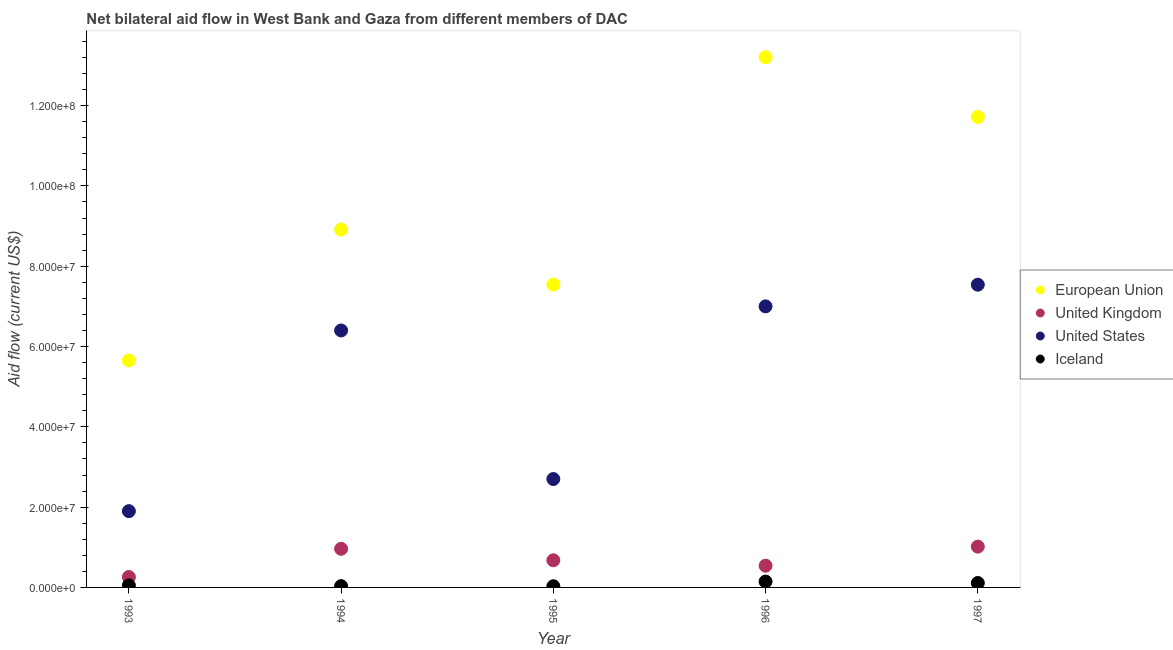How many different coloured dotlines are there?
Make the answer very short. 4. What is the amount of aid given by us in 1994?
Your response must be concise. 6.40e+07. Across all years, what is the maximum amount of aid given by uk?
Your response must be concise. 1.02e+07. Across all years, what is the minimum amount of aid given by us?
Provide a succinct answer. 1.90e+07. In which year was the amount of aid given by uk maximum?
Offer a very short reply. 1997. In which year was the amount of aid given by eu minimum?
Keep it short and to the point. 1993. What is the total amount of aid given by iceland in the graph?
Provide a succinct answer. 3.67e+06. What is the difference between the amount of aid given by iceland in 1996 and that in 1997?
Make the answer very short. 3.60e+05. What is the difference between the amount of aid given by iceland in 1994 and the amount of aid given by eu in 1993?
Offer a terse response. -5.62e+07. What is the average amount of aid given by iceland per year?
Your response must be concise. 7.34e+05. In the year 1997, what is the difference between the amount of aid given by uk and amount of aid given by eu?
Make the answer very short. -1.07e+08. What is the ratio of the amount of aid given by iceland in 1994 to that in 1996?
Ensure brevity in your answer.  0.22. Is the amount of aid given by uk in 1993 less than that in 1997?
Keep it short and to the point. Yes. Is the difference between the amount of aid given by us in 1995 and 1997 greater than the difference between the amount of aid given by eu in 1995 and 1997?
Keep it short and to the point. No. What is the difference between the highest and the second highest amount of aid given by eu?
Offer a terse response. 1.49e+07. What is the difference between the highest and the lowest amount of aid given by uk?
Give a very brief answer. 7.57e+06. In how many years, is the amount of aid given by eu greater than the average amount of aid given by eu taken over all years?
Ensure brevity in your answer.  2. Is the sum of the amount of aid given by iceland in 1994 and 1996 greater than the maximum amount of aid given by uk across all years?
Offer a very short reply. No. Is it the case that in every year, the sum of the amount of aid given by eu and amount of aid given by uk is greater than the amount of aid given by us?
Provide a short and direct response. Yes. Is the amount of aid given by us strictly less than the amount of aid given by eu over the years?
Ensure brevity in your answer.  Yes. What is the difference between two consecutive major ticks on the Y-axis?
Provide a short and direct response. 2.00e+07. Are the values on the major ticks of Y-axis written in scientific E-notation?
Give a very brief answer. Yes. Does the graph contain any zero values?
Offer a very short reply. No. Where does the legend appear in the graph?
Offer a very short reply. Center right. How are the legend labels stacked?
Provide a short and direct response. Vertical. What is the title of the graph?
Provide a short and direct response. Net bilateral aid flow in West Bank and Gaza from different members of DAC. Does "Secondary general" appear as one of the legend labels in the graph?
Offer a very short reply. No. What is the label or title of the X-axis?
Your answer should be compact. Year. What is the Aid flow (current US$) in European Union in 1993?
Give a very brief answer. 5.65e+07. What is the Aid flow (current US$) of United Kingdom in 1993?
Provide a short and direct response. 2.59e+06. What is the Aid flow (current US$) in United States in 1993?
Your answer should be very brief. 1.90e+07. What is the Aid flow (current US$) of Iceland in 1993?
Give a very brief answer. 5.00e+05. What is the Aid flow (current US$) of European Union in 1994?
Offer a terse response. 8.91e+07. What is the Aid flow (current US$) in United Kingdom in 1994?
Provide a short and direct response. 9.62e+06. What is the Aid flow (current US$) in United States in 1994?
Provide a succinct answer. 6.40e+07. What is the Aid flow (current US$) in European Union in 1995?
Your answer should be very brief. 7.54e+07. What is the Aid flow (current US$) in United Kingdom in 1995?
Keep it short and to the point. 6.76e+06. What is the Aid flow (current US$) of United States in 1995?
Offer a very short reply. 2.70e+07. What is the Aid flow (current US$) in European Union in 1996?
Offer a very short reply. 1.32e+08. What is the Aid flow (current US$) in United Kingdom in 1996?
Give a very brief answer. 5.41e+06. What is the Aid flow (current US$) in United States in 1996?
Keep it short and to the point. 7.00e+07. What is the Aid flow (current US$) of Iceland in 1996?
Your response must be concise. 1.46e+06. What is the Aid flow (current US$) in European Union in 1997?
Provide a succinct answer. 1.17e+08. What is the Aid flow (current US$) in United Kingdom in 1997?
Give a very brief answer. 1.02e+07. What is the Aid flow (current US$) of United States in 1997?
Keep it short and to the point. 7.54e+07. What is the Aid flow (current US$) in Iceland in 1997?
Make the answer very short. 1.10e+06. Across all years, what is the maximum Aid flow (current US$) in European Union?
Make the answer very short. 1.32e+08. Across all years, what is the maximum Aid flow (current US$) in United Kingdom?
Your answer should be very brief. 1.02e+07. Across all years, what is the maximum Aid flow (current US$) of United States?
Make the answer very short. 7.54e+07. Across all years, what is the maximum Aid flow (current US$) in Iceland?
Your response must be concise. 1.46e+06. Across all years, what is the minimum Aid flow (current US$) of European Union?
Your answer should be compact. 5.65e+07. Across all years, what is the minimum Aid flow (current US$) in United Kingdom?
Your answer should be very brief. 2.59e+06. Across all years, what is the minimum Aid flow (current US$) of United States?
Your response must be concise. 1.90e+07. What is the total Aid flow (current US$) of European Union in the graph?
Offer a terse response. 4.70e+08. What is the total Aid flow (current US$) of United Kingdom in the graph?
Provide a succinct answer. 3.45e+07. What is the total Aid flow (current US$) in United States in the graph?
Your response must be concise. 2.55e+08. What is the total Aid flow (current US$) in Iceland in the graph?
Provide a short and direct response. 3.67e+06. What is the difference between the Aid flow (current US$) in European Union in 1993 and that in 1994?
Your response must be concise. -3.26e+07. What is the difference between the Aid flow (current US$) in United Kingdom in 1993 and that in 1994?
Your response must be concise. -7.03e+06. What is the difference between the Aid flow (current US$) in United States in 1993 and that in 1994?
Make the answer very short. -4.50e+07. What is the difference between the Aid flow (current US$) in European Union in 1993 and that in 1995?
Provide a short and direct response. -1.89e+07. What is the difference between the Aid flow (current US$) in United Kingdom in 1993 and that in 1995?
Offer a terse response. -4.17e+06. What is the difference between the Aid flow (current US$) in United States in 1993 and that in 1995?
Make the answer very short. -8.00e+06. What is the difference between the Aid flow (current US$) of European Union in 1993 and that in 1996?
Offer a very short reply. -7.55e+07. What is the difference between the Aid flow (current US$) in United Kingdom in 1993 and that in 1996?
Ensure brevity in your answer.  -2.82e+06. What is the difference between the Aid flow (current US$) in United States in 1993 and that in 1996?
Your answer should be compact. -5.10e+07. What is the difference between the Aid flow (current US$) in Iceland in 1993 and that in 1996?
Provide a succinct answer. -9.60e+05. What is the difference between the Aid flow (current US$) of European Union in 1993 and that in 1997?
Your answer should be compact. -6.06e+07. What is the difference between the Aid flow (current US$) of United Kingdom in 1993 and that in 1997?
Make the answer very short. -7.57e+06. What is the difference between the Aid flow (current US$) of United States in 1993 and that in 1997?
Ensure brevity in your answer.  -5.64e+07. What is the difference between the Aid flow (current US$) in Iceland in 1993 and that in 1997?
Ensure brevity in your answer.  -6.00e+05. What is the difference between the Aid flow (current US$) in European Union in 1994 and that in 1995?
Provide a succinct answer. 1.37e+07. What is the difference between the Aid flow (current US$) in United Kingdom in 1994 and that in 1995?
Make the answer very short. 2.86e+06. What is the difference between the Aid flow (current US$) of United States in 1994 and that in 1995?
Make the answer very short. 3.70e+07. What is the difference between the Aid flow (current US$) in European Union in 1994 and that in 1996?
Your answer should be very brief. -4.29e+07. What is the difference between the Aid flow (current US$) of United Kingdom in 1994 and that in 1996?
Make the answer very short. 4.21e+06. What is the difference between the Aid flow (current US$) in United States in 1994 and that in 1996?
Your answer should be very brief. -6.00e+06. What is the difference between the Aid flow (current US$) of Iceland in 1994 and that in 1996?
Your answer should be very brief. -1.14e+06. What is the difference between the Aid flow (current US$) in European Union in 1994 and that in 1997?
Make the answer very short. -2.80e+07. What is the difference between the Aid flow (current US$) of United Kingdom in 1994 and that in 1997?
Ensure brevity in your answer.  -5.40e+05. What is the difference between the Aid flow (current US$) of United States in 1994 and that in 1997?
Make the answer very short. -1.14e+07. What is the difference between the Aid flow (current US$) of Iceland in 1994 and that in 1997?
Offer a terse response. -7.80e+05. What is the difference between the Aid flow (current US$) in European Union in 1995 and that in 1996?
Provide a succinct answer. -5.66e+07. What is the difference between the Aid flow (current US$) in United Kingdom in 1995 and that in 1996?
Keep it short and to the point. 1.35e+06. What is the difference between the Aid flow (current US$) in United States in 1995 and that in 1996?
Provide a short and direct response. -4.30e+07. What is the difference between the Aid flow (current US$) of Iceland in 1995 and that in 1996?
Your answer should be very brief. -1.17e+06. What is the difference between the Aid flow (current US$) in European Union in 1995 and that in 1997?
Offer a very short reply. -4.18e+07. What is the difference between the Aid flow (current US$) of United Kingdom in 1995 and that in 1997?
Your answer should be compact. -3.40e+06. What is the difference between the Aid flow (current US$) in United States in 1995 and that in 1997?
Offer a very short reply. -4.84e+07. What is the difference between the Aid flow (current US$) of Iceland in 1995 and that in 1997?
Ensure brevity in your answer.  -8.10e+05. What is the difference between the Aid flow (current US$) of European Union in 1996 and that in 1997?
Your answer should be very brief. 1.49e+07. What is the difference between the Aid flow (current US$) in United Kingdom in 1996 and that in 1997?
Provide a short and direct response. -4.75e+06. What is the difference between the Aid flow (current US$) of United States in 1996 and that in 1997?
Give a very brief answer. -5.40e+06. What is the difference between the Aid flow (current US$) of Iceland in 1996 and that in 1997?
Keep it short and to the point. 3.60e+05. What is the difference between the Aid flow (current US$) of European Union in 1993 and the Aid flow (current US$) of United Kingdom in 1994?
Your answer should be very brief. 4.69e+07. What is the difference between the Aid flow (current US$) in European Union in 1993 and the Aid flow (current US$) in United States in 1994?
Keep it short and to the point. -7.48e+06. What is the difference between the Aid flow (current US$) of European Union in 1993 and the Aid flow (current US$) of Iceland in 1994?
Make the answer very short. 5.62e+07. What is the difference between the Aid flow (current US$) of United Kingdom in 1993 and the Aid flow (current US$) of United States in 1994?
Give a very brief answer. -6.14e+07. What is the difference between the Aid flow (current US$) of United Kingdom in 1993 and the Aid flow (current US$) of Iceland in 1994?
Give a very brief answer. 2.27e+06. What is the difference between the Aid flow (current US$) in United States in 1993 and the Aid flow (current US$) in Iceland in 1994?
Keep it short and to the point. 1.87e+07. What is the difference between the Aid flow (current US$) in European Union in 1993 and the Aid flow (current US$) in United Kingdom in 1995?
Your answer should be compact. 4.98e+07. What is the difference between the Aid flow (current US$) in European Union in 1993 and the Aid flow (current US$) in United States in 1995?
Give a very brief answer. 2.95e+07. What is the difference between the Aid flow (current US$) in European Union in 1993 and the Aid flow (current US$) in Iceland in 1995?
Ensure brevity in your answer.  5.62e+07. What is the difference between the Aid flow (current US$) in United Kingdom in 1993 and the Aid flow (current US$) in United States in 1995?
Your answer should be compact. -2.44e+07. What is the difference between the Aid flow (current US$) of United Kingdom in 1993 and the Aid flow (current US$) of Iceland in 1995?
Provide a succinct answer. 2.30e+06. What is the difference between the Aid flow (current US$) of United States in 1993 and the Aid flow (current US$) of Iceland in 1995?
Your answer should be compact. 1.87e+07. What is the difference between the Aid flow (current US$) of European Union in 1993 and the Aid flow (current US$) of United Kingdom in 1996?
Make the answer very short. 5.11e+07. What is the difference between the Aid flow (current US$) of European Union in 1993 and the Aid flow (current US$) of United States in 1996?
Provide a succinct answer. -1.35e+07. What is the difference between the Aid flow (current US$) of European Union in 1993 and the Aid flow (current US$) of Iceland in 1996?
Offer a very short reply. 5.51e+07. What is the difference between the Aid flow (current US$) in United Kingdom in 1993 and the Aid flow (current US$) in United States in 1996?
Offer a very short reply. -6.74e+07. What is the difference between the Aid flow (current US$) of United Kingdom in 1993 and the Aid flow (current US$) of Iceland in 1996?
Your answer should be very brief. 1.13e+06. What is the difference between the Aid flow (current US$) in United States in 1993 and the Aid flow (current US$) in Iceland in 1996?
Your response must be concise. 1.75e+07. What is the difference between the Aid flow (current US$) of European Union in 1993 and the Aid flow (current US$) of United Kingdom in 1997?
Keep it short and to the point. 4.64e+07. What is the difference between the Aid flow (current US$) of European Union in 1993 and the Aid flow (current US$) of United States in 1997?
Ensure brevity in your answer.  -1.89e+07. What is the difference between the Aid flow (current US$) in European Union in 1993 and the Aid flow (current US$) in Iceland in 1997?
Keep it short and to the point. 5.54e+07. What is the difference between the Aid flow (current US$) of United Kingdom in 1993 and the Aid flow (current US$) of United States in 1997?
Offer a terse response. -7.28e+07. What is the difference between the Aid flow (current US$) in United Kingdom in 1993 and the Aid flow (current US$) in Iceland in 1997?
Your answer should be very brief. 1.49e+06. What is the difference between the Aid flow (current US$) in United States in 1993 and the Aid flow (current US$) in Iceland in 1997?
Your answer should be compact. 1.79e+07. What is the difference between the Aid flow (current US$) of European Union in 1994 and the Aid flow (current US$) of United Kingdom in 1995?
Make the answer very short. 8.24e+07. What is the difference between the Aid flow (current US$) of European Union in 1994 and the Aid flow (current US$) of United States in 1995?
Offer a terse response. 6.21e+07. What is the difference between the Aid flow (current US$) in European Union in 1994 and the Aid flow (current US$) in Iceland in 1995?
Keep it short and to the point. 8.88e+07. What is the difference between the Aid flow (current US$) of United Kingdom in 1994 and the Aid flow (current US$) of United States in 1995?
Offer a very short reply. -1.74e+07. What is the difference between the Aid flow (current US$) of United Kingdom in 1994 and the Aid flow (current US$) of Iceland in 1995?
Offer a terse response. 9.33e+06. What is the difference between the Aid flow (current US$) of United States in 1994 and the Aid flow (current US$) of Iceland in 1995?
Your answer should be compact. 6.37e+07. What is the difference between the Aid flow (current US$) in European Union in 1994 and the Aid flow (current US$) in United Kingdom in 1996?
Make the answer very short. 8.37e+07. What is the difference between the Aid flow (current US$) in European Union in 1994 and the Aid flow (current US$) in United States in 1996?
Keep it short and to the point. 1.91e+07. What is the difference between the Aid flow (current US$) of European Union in 1994 and the Aid flow (current US$) of Iceland in 1996?
Offer a terse response. 8.77e+07. What is the difference between the Aid flow (current US$) of United Kingdom in 1994 and the Aid flow (current US$) of United States in 1996?
Your answer should be compact. -6.04e+07. What is the difference between the Aid flow (current US$) in United Kingdom in 1994 and the Aid flow (current US$) in Iceland in 1996?
Keep it short and to the point. 8.16e+06. What is the difference between the Aid flow (current US$) in United States in 1994 and the Aid flow (current US$) in Iceland in 1996?
Offer a terse response. 6.25e+07. What is the difference between the Aid flow (current US$) of European Union in 1994 and the Aid flow (current US$) of United Kingdom in 1997?
Provide a succinct answer. 7.90e+07. What is the difference between the Aid flow (current US$) of European Union in 1994 and the Aid flow (current US$) of United States in 1997?
Make the answer very short. 1.37e+07. What is the difference between the Aid flow (current US$) of European Union in 1994 and the Aid flow (current US$) of Iceland in 1997?
Provide a succinct answer. 8.80e+07. What is the difference between the Aid flow (current US$) in United Kingdom in 1994 and the Aid flow (current US$) in United States in 1997?
Your answer should be compact. -6.58e+07. What is the difference between the Aid flow (current US$) of United Kingdom in 1994 and the Aid flow (current US$) of Iceland in 1997?
Provide a short and direct response. 8.52e+06. What is the difference between the Aid flow (current US$) in United States in 1994 and the Aid flow (current US$) in Iceland in 1997?
Offer a terse response. 6.29e+07. What is the difference between the Aid flow (current US$) in European Union in 1995 and the Aid flow (current US$) in United Kingdom in 1996?
Your answer should be very brief. 7.00e+07. What is the difference between the Aid flow (current US$) in European Union in 1995 and the Aid flow (current US$) in United States in 1996?
Provide a succinct answer. 5.41e+06. What is the difference between the Aid flow (current US$) in European Union in 1995 and the Aid flow (current US$) in Iceland in 1996?
Provide a succinct answer. 7.40e+07. What is the difference between the Aid flow (current US$) of United Kingdom in 1995 and the Aid flow (current US$) of United States in 1996?
Make the answer very short. -6.32e+07. What is the difference between the Aid flow (current US$) of United Kingdom in 1995 and the Aid flow (current US$) of Iceland in 1996?
Make the answer very short. 5.30e+06. What is the difference between the Aid flow (current US$) in United States in 1995 and the Aid flow (current US$) in Iceland in 1996?
Ensure brevity in your answer.  2.55e+07. What is the difference between the Aid flow (current US$) of European Union in 1995 and the Aid flow (current US$) of United Kingdom in 1997?
Your response must be concise. 6.52e+07. What is the difference between the Aid flow (current US$) of European Union in 1995 and the Aid flow (current US$) of United States in 1997?
Keep it short and to the point. 10000. What is the difference between the Aid flow (current US$) in European Union in 1995 and the Aid flow (current US$) in Iceland in 1997?
Your answer should be compact. 7.43e+07. What is the difference between the Aid flow (current US$) of United Kingdom in 1995 and the Aid flow (current US$) of United States in 1997?
Offer a terse response. -6.86e+07. What is the difference between the Aid flow (current US$) in United Kingdom in 1995 and the Aid flow (current US$) in Iceland in 1997?
Offer a very short reply. 5.66e+06. What is the difference between the Aid flow (current US$) in United States in 1995 and the Aid flow (current US$) in Iceland in 1997?
Offer a terse response. 2.59e+07. What is the difference between the Aid flow (current US$) in European Union in 1996 and the Aid flow (current US$) in United Kingdom in 1997?
Your answer should be very brief. 1.22e+08. What is the difference between the Aid flow (current US$) in European Union in 1996 and the Aid flow (current US$) in United States in 1997?
Give a very brief answer. 5.66e+07. What is the difference between the Aid flow (current US$) of European Union in 1996 and the Aid flow (current US$) of Iceland in 1997?
Ensure brevity in your answer.  1.31e+08. What is the difference between the Aid flow (current US$) of United Kingdom in 1996 and the Aid flow (current US$) of United States in 1997?
Provide a short and direct response. -7.00e+07. What is the difference between the Aid flow (current US$) of United Kingdom in 1996 and the Aid flow (current US$) of Iceland in 1997?
Make the answer very short. 4.31e+06. What is the difference between the Aid flow (current US$) in United States in 1996 and the Aid flow (current US$) in Iceland in 1997?
Provide a short and direct response. 6.89e+07. What is the average Aid flow (current US$) in European Union per year?
Offer a terse response. 9.41e+07. What is the average Aid flow (current US$) of United Kingdom per year?
Provide a short and direct response. 6.91e+06. What is the average Aid flow (current US$) in United States per year?
Offer a terse response. 5.11e+07. What is the average Aid flow (current US$) in Iceland per year?
Your answer should be compact. 7.34e+05. In the year 1993, what is the difference between the Aid flow (current US$) in European Union and Aid flow (current US$) in United Kingdom?
Offer a terse response. 5.39e+07. In the year 1993, what is the difference between the Aid flow (current US$) of European Union and Aid flow (current US$) of United States?
Your answer should be very brief. 3.75e+07. In the year 1993, what is the difference between the Aid flow (current US$) in European Union and Aid flow (current US$) in Iceland?
Your answer should be compact. 5.60e+07. In the year 1993, what is the difference between the Aid flow (current US$) of United Kingdom and Aid flow (current US$) of United States?
Keep it short and to the point. -1.64e+07. In the year 1993, what is the difference between the Aid flow (current US$) in United Kingdom and Aid flow (current US$) in Iceland?
Give a very brief answer. 2.09e+06. In the year 1993, what is the difference between the Aid flow (current US$) of United States and Aid flow (current US$) of Iceland?
Provide a succinct answer. 1.85e+07. In the year 1994, what is the difference between the Aid flow (current US$) of European Union and Aid flow (current US$) of United Kingdom?
Provide a short and direct response. 7.95e+07. In the year 1994, what is the difference between the Aid flow (current US$) in European Union and Aid flow (current US$) in United States?
Provide a succinct answer. 2.51e+07. In the year 1994, what is the difference between the Aid flow (current US$) in European Union and Aid flow (current US$) in Iceland?
Keep it short and to the point. 8.88e+07. In the year 1994, what is the difference between the Aid flow (current US$) of United Kingdom and Aid flow (current US$) of United States?
Offer a very short reply. -5.44e+07. In the year 1994, what is the difference between the Aid flow (current US$) in United Kingdom and Aid flow (current US$) in Iceland?
Offer a terse response. 9.30e+06. In the year 1994, what is the difference between the Aid flow (current US$) in United States and Aid flow (current US$) in Iceland?
Provide a short and direct response. 6.37e+07. In the year 1995, what is the difference between the Aid flow (current US$) of European Union and Aid flow (current US$) of United Kingdom?
Your answer should be very brief. 6.86e+07. In the year 1995, what is the difference between the Aid flow (current US$) in European Union and Aid flow (current US$) in United States?
Offer a very short reply. 4.84e+07. In the year 1995, what is the difference between the Aid flow (current US$) in European Union and Aid flow (current US$) in Iceland?
Your answer should be very brief. 7.51e+07. In the year 1995, what is the difference between the Aid flow (current US$) in United Kingdom and Aid flow (current US$) in United States?
Your answer should be very brief. -2.02e+07. In the year 1995, what is the difference between the Aid flow (current US$) of United Kingdom and Aid flow (current US$) of Iceland?
Offer a terse response. 6.47e+06. In the year 1995, what is the difference between the Aid flow (current US$) of United States and Aid flow (current US$) of Iceland?
Provide a short and direct response. 2.67e+07. In the year 1996, what is the difference between the Aid flow (current US$) in European Union and Aid flow (current US$) in United Kingdom?
Your response must be concise. 1.27e+08. In the year 1996, what is the difference between the Aid flow (current US$) of European Union and Aid flow (current US$) of United States?
Your answer should be very brief. 6.20e+07. In the year 1996, what is the difference between the Aid flow (current US$) of European Union and Aid flow (current US$) of Iceland?
Provide a short and direct response. 1.31e+08. In the year 1996, what is the difference between the Aid flow (current US$) in United Kingdom and Aid flow (current US$) in United States?
Give a very brief answer. -6.46e+07. In the year 1996, what is the difference between the Aid flow (current US$) in United Kingdom and Aid flow (current US$) in Iceland?
Provide a short and direct response. 3.95e+06. In the year 1996, what is the difference between the Aid flow (current US$) in United States and Aid flow (current US$) in Iceland?
Keep it short and to the point. 6.85e+07. In the year 1997, what is the difference between the Aid flow (current US$) in European Union and Aid flow (current US$) in United Kingdom?
Give a very brief answer. 1.07e+08. In the year 1997, what is the difference between the Aid flow (current US$) of European Union and Aid flow (current US$) of United States?
Offer a very short reply. 4.18e+07. In the year 1997, what is the difference between the Aid flow (current US$) in European Union and Aid flow (current US$) in Iceland?
Provide a short and direct response. 1.16e+08. In the year 1997, what is the difference between the Aid flow (current US$) in United Kingdom and Aid flow (current US$) in United States?
Make the answer very short. -6.52e+07. In the year 1997, what is the difference between the Aid flow (current US$) of United Kingdom and Aid flow (current US$) of Iceland?
Ensure brevity in your answer.  9.06e+06. In the year 1997, what is the difference between the Aid flow (current US$) of United States and Aid flow (current US$) of Iceland?
Your answer should be very brief. 7.43e+07. What is the ratio of the Aid flow (current US$) of European Union in 1993 to that in 1994?
Your response must be concise. 0.63. What is the ratio of the Aid flow (current US$) in United Kingdom in 1993 to that in 1994?
Offer a very short reply. 0.27. What is the ratio of the Aid flow (current US$) of United States in 1993 to that in 1994?
Offer a very short reply. 0.3. What is the ratio of the Aid flow (current US$) of Iceland in 1993 to that in 1994?
Your answer should be compact. 1.56. What is the ratio of the Aid flow (current US$) of European Union in 1993 to that in 1995?
Offer a very short reply. 0.75. What is the ratio of the Aid flow (current US$) of United Kingdom in 1993 to that in 1995?
Make the answer very short. 0.38. What is the ratio of the Aid flow (current US$) in United States in 1993 to that in 1995?
Your response must be concise. 0.7. What is the ratio of the Aid flow (current US$) of Iceland in 1993 to that in 1995?
Provide a short and direct response. 1.72. What is the ratio of the Aid flow (current US$) in European Union in 1993 to that in 1996?
Provide a short and direct response. 0.43. What is the ratio of the Aid flow (current US$) in United Kingdom in 1993 to that in 1996?
Offer a very short reply. 0.48. What is the ratio of the Aid flow (current US$) of United States in 1993 to that in 1996?
Provide a short and direct response. 0.27. What is the ratio of the Aid flow (current US$) in Iceland in 1993 to that in 1996?
Offer a terse response. 0.34. What is the ratio of the Aid flow (current US$) in European Union in 1993 to that in 1997?
Provide a succinct answer. 0.48. What is the ratio of the Aid flow (current US$) in United Kingdom in 1993 to that in 1997?
Your answer should be compact. 0.25. What is the ratio of the Aid flow (current US$) in United States in 1993 to that in 1997?
Keep it short and to the point. 0.25. What is the ratio of the Aid flow (current US$) in Iceland in 1993 to that in 1997?
Ensure brevity in your answer.  0.45. What is the ratio of the Aid flow (current US$) of European Union in 1994 to that in 1995?
Your answer should be very brief. 1.18. What is the ratio of the Aid flow (current US$) in United Kingdom in 1994 to that in 1995?
Provide a short and direct response. 1.42. What is the ratio of the Aid flow (current US$) of United States in 1994 to that in 1995?
Give a very brief answer. 2.37. What is the ratio of the Aid flow (current US$) in Iceland in 1994 to that in 1995?
Give a very brief answer. 1.1. What is the ratio of the Aid flow (current US$) of European Union in 1994 to that in 1996?
Your answer should be very brief. 0.68. What is the ratio of the Aid flow (current US$) in United Kingdom in 1994 to that in 1996?
Keep it short and to the point. 1.78. What is the ratio of the Aid flow (current US$) in United States in 1994 to that in 1996?
Provide a short and direct response. 0.91. What is the ratio of the Aid flow (current US$) in Iceland in 1994 to that in 1996?
Offer a very short reply. 0.22. What is the ratio of the Aid flow (current US$) of European Union in 1994 to that in 1997?
Ensure brevity in your answer.  0.76. What is the ratio of the Aid flow (current US$) of United Kingdom in 1994 to that in 1997?
Offer a terse response. 0.95. What is the ratio of the Aid flow (current US$) of United States in 1994 to that in 1997?
Your answer should be compact. 0.85. What is the ratio of the Aid flow (current US$) of Iceland in 1994 to that in 1997?
Offer a very short reply. 0.29. What is the ratio of the Aid flow (current US$) of European Union in 1995 to that in 1996?
Provide a succinct answer. 0.57. What is the ratio of the Aid flow (current US$) of United Kingdom in 1995 to that in 1996?
Provide a short and direct response. 1.25. What is the ratio of the Aid flow (current US$) in United States in 1995 to that in 1996?
Your response must be concise. 0.39. What is the ratio of the Aid flow (current US$) of Iceland in 1995 to that in 1996?
Your response must be concise. 0.2. What is the ratio of the Aid flow (current US$) of European Union in 1995 to that in 1997?
Your answer should be very brief. 0.64. What is the ratio of the Aid flow (current US$) in United Kingdom in 1995 to that in 1997?
Provide a succinct answer. 0.67. What is the ratio of the Aid flow (current US$) of United States in 1995 to that in 1997?
Keep it short and to the point. 0.36. What is the ratio of the Aid flow (current US$) of Iceland in 1995 to that in 1997?
Offer a very short reply. 0.26. What is the ratio of the Aid flow (current US$) in European Union in 1996 to that in 1997?
Offer a terse response. 1.13. What is the ratio of the Aid flow (current US$) in United Kingdom in 1996 to that in 1997?
Offer a terse response. 0.53. What is the ratio of the Aid flow (current US$) of United States in 1996 to that in 1997?
Ensure brevity in your answer.  0.93. What is the ratio of the Aid flow (current US$) in Iceland in 1996 to that in 1997?
Offer a terse response. 1.33. What is the difference between the highest and the second highest Aid flow (current US$) of European Union?
Offer a very short reply. 1.49e+07. What is the difference between the highest and the second highest Aid flow (current US$) of United Kingdom?
Make the answer very short. 5.40e+05. What is the difference between the highest and the second highest Aid flow (current US$) of United States?
Make the answer very short. 5.40e+06. What is the difference between the highest and the second highest Aid flow (current US$) in Iceland?
Offer a terse response. 3.60e+05. What is the difference between the highest and the lowest Aid flow (current US$) of European Union?
Give a very brief answer. 7.55e+07. What is the difference between the highest and the lowest Aid flow (current US$) in United Kingdom?
Keep it short and to the point. 7.57e+06. What is the difference between the highest and the lowest Aid flow (current US$) in United States?
Your response must be concise. 5.64e+07. What is the difference between the highest and the lowest Aid flow (current US$) of Iceland?
Provide a succinct answer. 1.17e+06. 